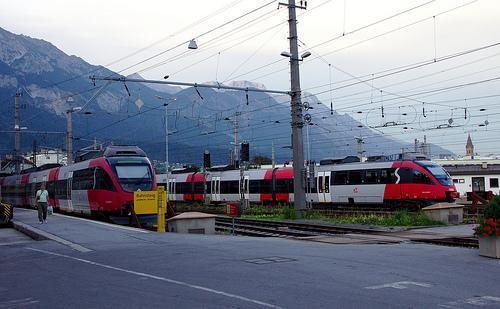How many trains are there?
Give a very brief answer. 2. How many tracks are there?
Give a very brief answer. 4. 